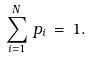<formula> <loc_0><loc_0><loc_500><loc_500>\sum _ { i = 1 } ^ { N } \, p _ { i } \, = \, 1 .</formula> 